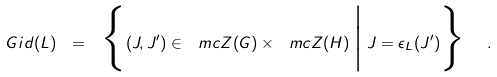Convert formula to latex. <formula><loc_0><loc_0><loc_500><loc_500>\ G i d ( L ) \ = \ \Big \{ ( J , J ^ { \prime } ) \in \ m c { Z } ( G ) \times \ m c { Z } ( H ) \, \Big | \, J = \epsilon _ { L } ( J ^ { \prime } ) \Big \} \ \ .</formula> 